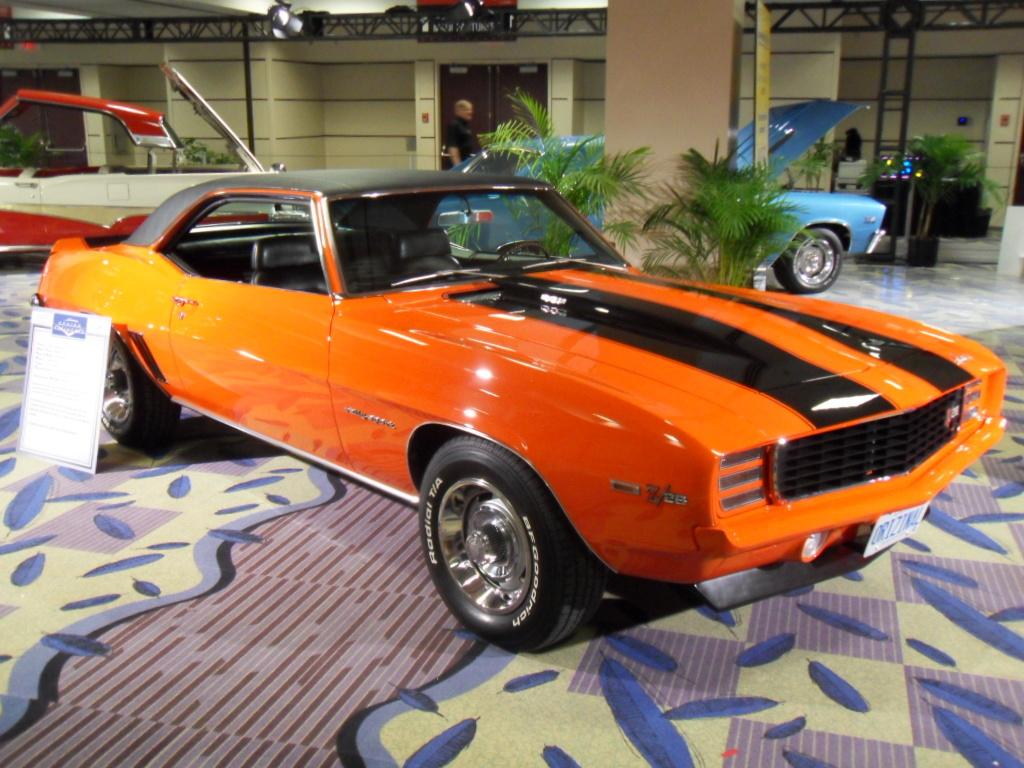What objects are on the floor in the image? There are cars on the floor in the image. What can be seen in the background of the image? There is a building visible in the image. Can you describe the person in the image? A person is standing in front of the building. How many balls are being juggled by the person in the image? There are no balls present in the image; the person is standing in front of a building. What type of pets can be seen in the image? There are no pets visible in the image; it features cars on the floor and a person standing in front of a building. 